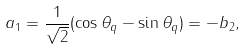<formula> <loc_0><loc_0><loc_500><loc_500>a _ { 1 } = \frac { 1 } { \sqrt { 2 } } ( \cos \theta _ { q } - \sin \theta _ { q } ) = - b _ { 2 } ,</formula> 